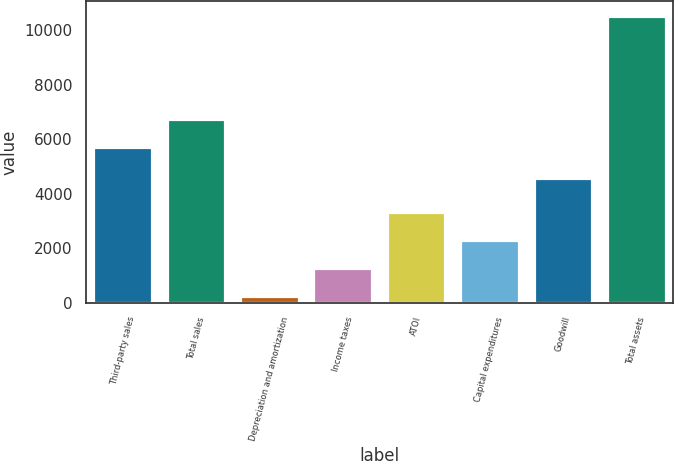Convert chart to OTSL. <chart><loc_0><loc_0><loc_500><loc_500><bar_chart><fcel>Third-party sales<fcel>Total sales<fcel>Depreciation and amortization<fcel>Income taxes<fcel>ATOI<fcel>Capital expenditures<fcel>Goodwill<fcel>Total assets<nl><fcel>5728<fcel>6756.7<fcel>255<fcel>1283.7<fcel>3341.1<fcel>2312.4<fcel>4579<fcel>10542<nl></chart> 